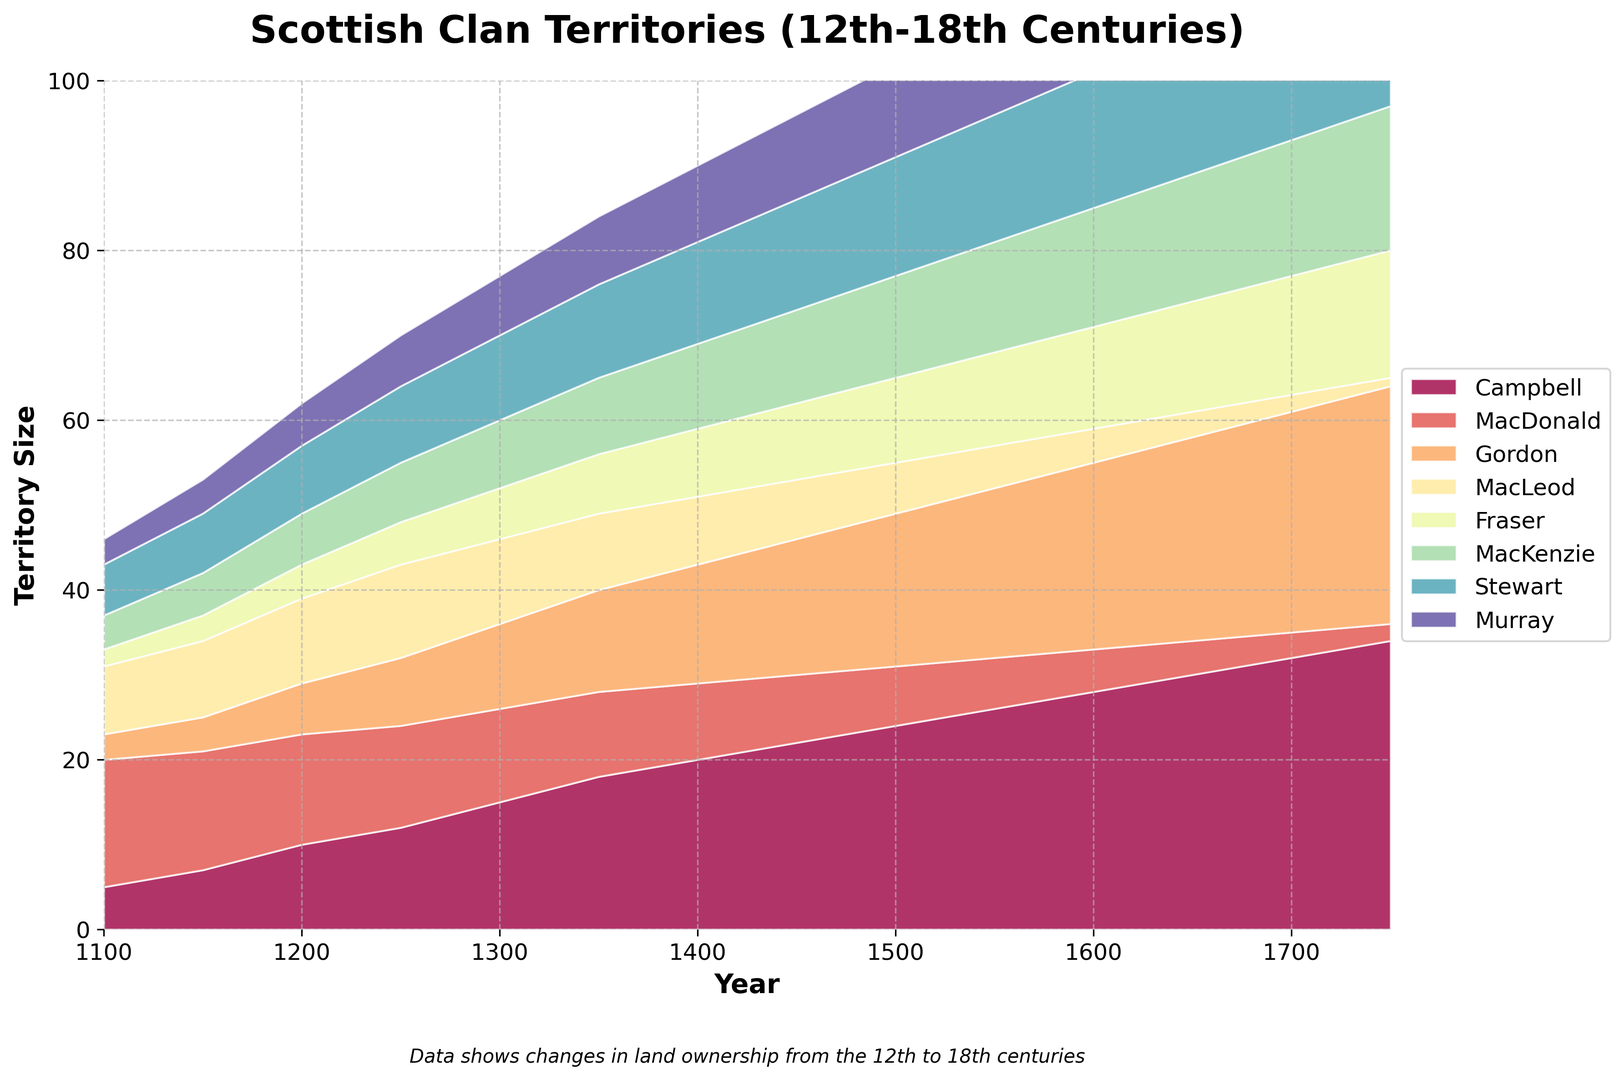Which clan had the most significant increase in territory size between 1100 and 1750? To find out which clan had the most significant increase in territory size, we need to compare the territory size in 1750 to the size in 1100 for each clan. Campbell increased from 5 to 34, a gain of 29; MacDonald decreased from 15 to 2; Gordon increased from 3 to 28, a gain of 25; MacLeod decreased from 8 to 1; Fraser increased from 2 to 15, a gain of 13; MacKenzie increased from 4 to 17, a gain of 13; Stewart increased from 6 to 19, a gain of 13; Murray increased from 3 to 16, a gain of 13. Campbell had the most significant increase.
Answer: Campbell Which clan had the smallest territory size in the year 1650? By looking at the chart for the year 1650, we find the clan with the smallest territory size. The values are: Campbell 30, MacDonald 4, Gordon 24, MacLeod 3, Fraser 13, MacKenzie 15, Stewart 17, Murray 14. Thus, MacLeod has the smallest territory size.
Answer: MacLeod Between which two consecutive centuries did Campbell’s territory size increase the most? To find this, we need to compute the increase in size for Campbell’s territory between each consecutive 50-year period: from 1100 to 1150 (7-5=2), from 1150 to 1200 (10-7=3), from 1200 to 1250 (12-10=2), from 1250 to 1300 (15-12=3), from 1300 to 1350 (18-15=3), from 1350 to 1400 (20-18=2), from 1400 to 1450 (22-20=2), from 1450 to 1500 (24-22=2), from 1500 to 1550 (26-24=2), from 1550 to 1600 (28-26=2), from 1600 to 1650 (30-28=2), from 1650 to 1700 (32-30=2), from 1700 to 1750 (34-32=2). The largest increase is from 1150 to 1200 and 1250 to 1300 which is 3.
Answer: 1150 to 1200 and 1250 to 1300 Which clan had a constant increase in its territory size throughout the timeline? We need to analyze the data for each clan and check if the values continuously increase. Campbell starts at 5 and increases to 34; Gordon starts at 3 and increases to 28; Fraser starts at 2 and increases to 15; MacKenzie starts at 4 and increases to 17; Stewart starts at 6 and increases to 19; Murray starts at 3 and increases to 16. These clans all show constant increase. MacLeod and MacDonald show decreases at various points, so they aren’t considered.
Answer: Campbell, Gordon, Fraser, MacKenzie, Stewart, Murray In what year did the total territory size owned by Campbell and Gordon equally match that of Stewart? We need to sum the territory sizes of Campbell and Gordon for each year and compare it to the size of Stewart. By examining the chart, in 1300, Campbell (15) + Gordon (10) = 25 and Stewart also shows 10; hence, they match.
Answer: 1300 Which clan’s territory size decreased the most dramatically and when did this occur? To find this, we need to identify the timescale and compare the changes for each clan. The data show that MacDonald’s size went from 15 in1100 to 2 in 1700, a decrease of 13. That’s the most dramatic consistent decrease.
Answer: MacDonald What was the relative proportion of MacKenzie’s land to the total territory size in 1600? First, calculate the total size of all territories in 1600: Campbell 28, MacDonald 5, Gordon 22, MacLeod 4, Fraser 12, MacKenzie 14, Stewart 16, Murray 13. Total = 114. MacKenzie’s proportion = 14/114 ≈ 12.3%.
Answer: 12.3% 